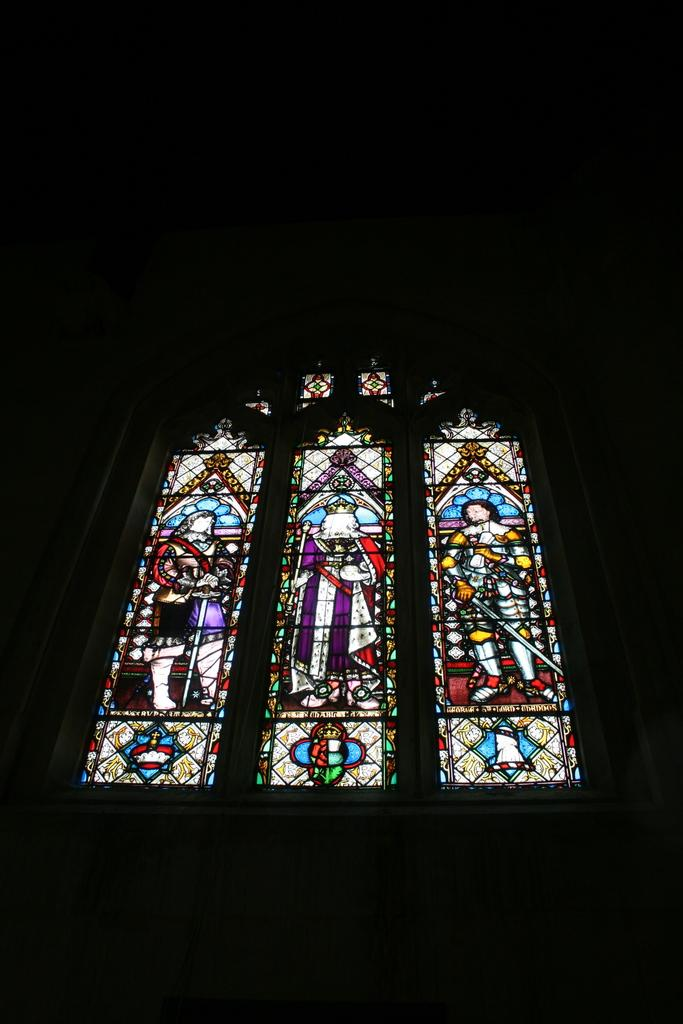What can be seen in the image that provides a view or access to the outside? There is a window in the image. What is unique about the appearance of the window? The glass of the window is colorful. How many people can be seen on the window? Three persons are visible on the window. What is the color of the background around the window? The background around the window is black. How many times do the persons on the window fold their arms in the image? There is no information about the persons' arm positions in the image, so it cannot be determined how many times they fold their arms. 